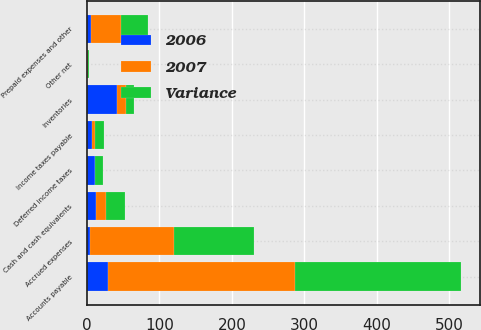Convert chart. <chart><loc_0><loc_0><loc_500><loc_500><stacked_bar_chart><ecel><fcel>Cash and cash equivalents<fcel>Inventories<fcel>Prepaid expenses and other<fcel>Deferred income taxes<fcel>Accounts payable<fcel>Accrued expenses<fcel>Income taxes payable<fcel>Other net<nl><fcel>2007<fcel>13.7<fcel>12.1<fcel>41.9<fcel>0.3<fcel>258.3<fcel>115.6<fcel>5.1<fcel>0.8<nl><fcel>Variance<fcel>26.4<fcel>12.1<fcel>37<fcel>11.3<fcel>229.2<fcel>111.7<fcel>11.5<fcel>1.1<nl><fcel>2006<fcel>12.7<fcel>41.1<fcel>4.9<fcel>11<fcel>29.1<fcel>3.9<fcel>6.4<fcel>0.3<nl></chart> 